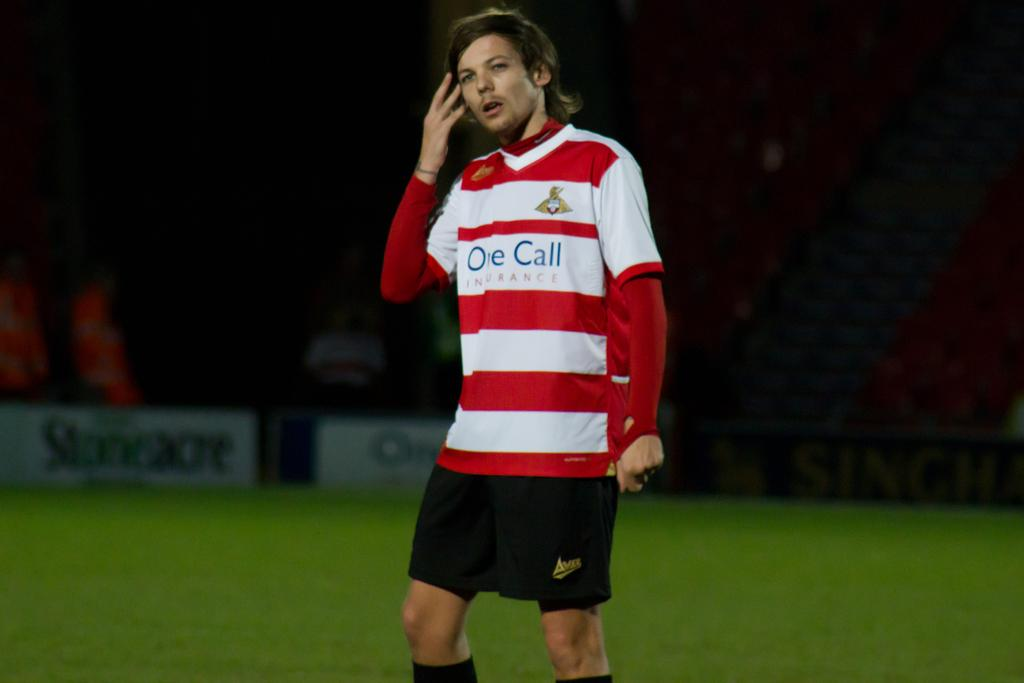<image>
Provide a brief description of the given image. a player that has the name one call on their shirt 